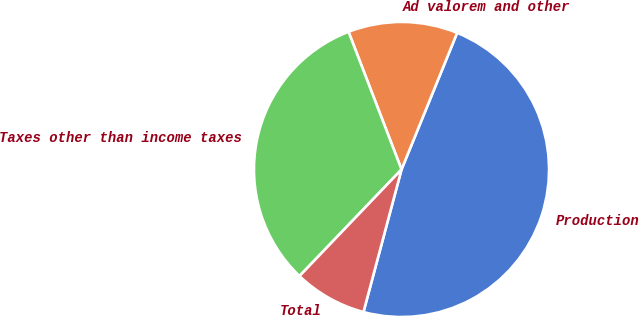Convert chart. <chart><loc_0><loc_0><loc_500><loc_500><pie_chart><fcel>Production<fcel>Ad valorem and other<fcel>Taxes other than income taxes<fcel>Total<nl><fcel>48.0%<fcel>12.0%<fcel>32.0%<fcel>8.0%<nl></chart> 